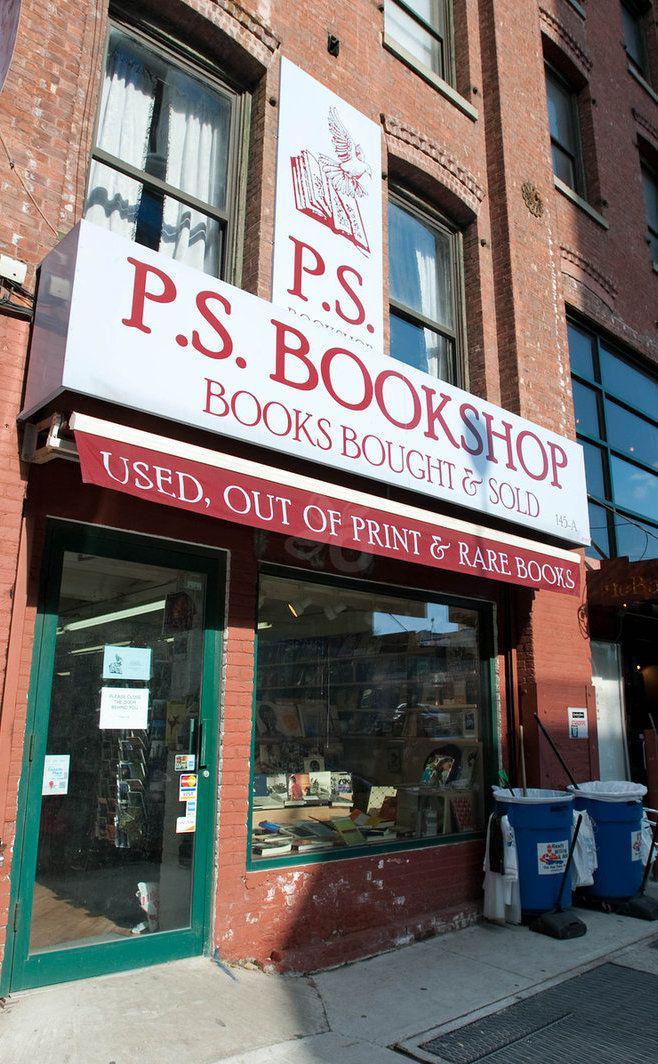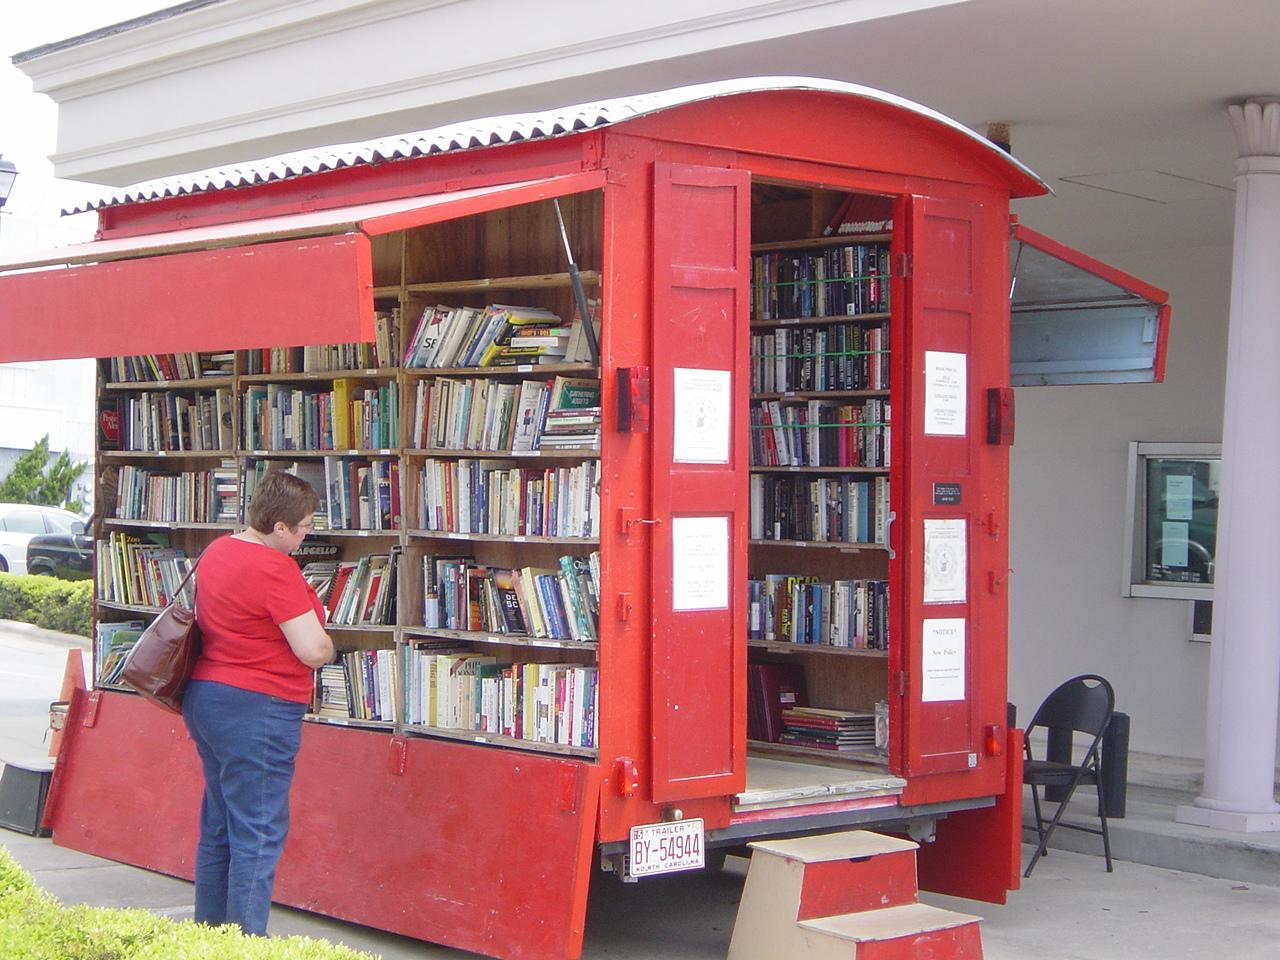The first image is the image on the left, the second image is the image on the right. Assess this claim about the two images: "there is a bookstore in a brick building with green painted trim on the door and window". Correct or not? Answer yes or no. Yes. The first image is the image on the left, the second image is the image on the right. Examine the images to the left and right. Is the description "The left image depicts a painted red bookshop exterior with some type of awning over its front door and display window." accurate? Answer yes or no. No. 